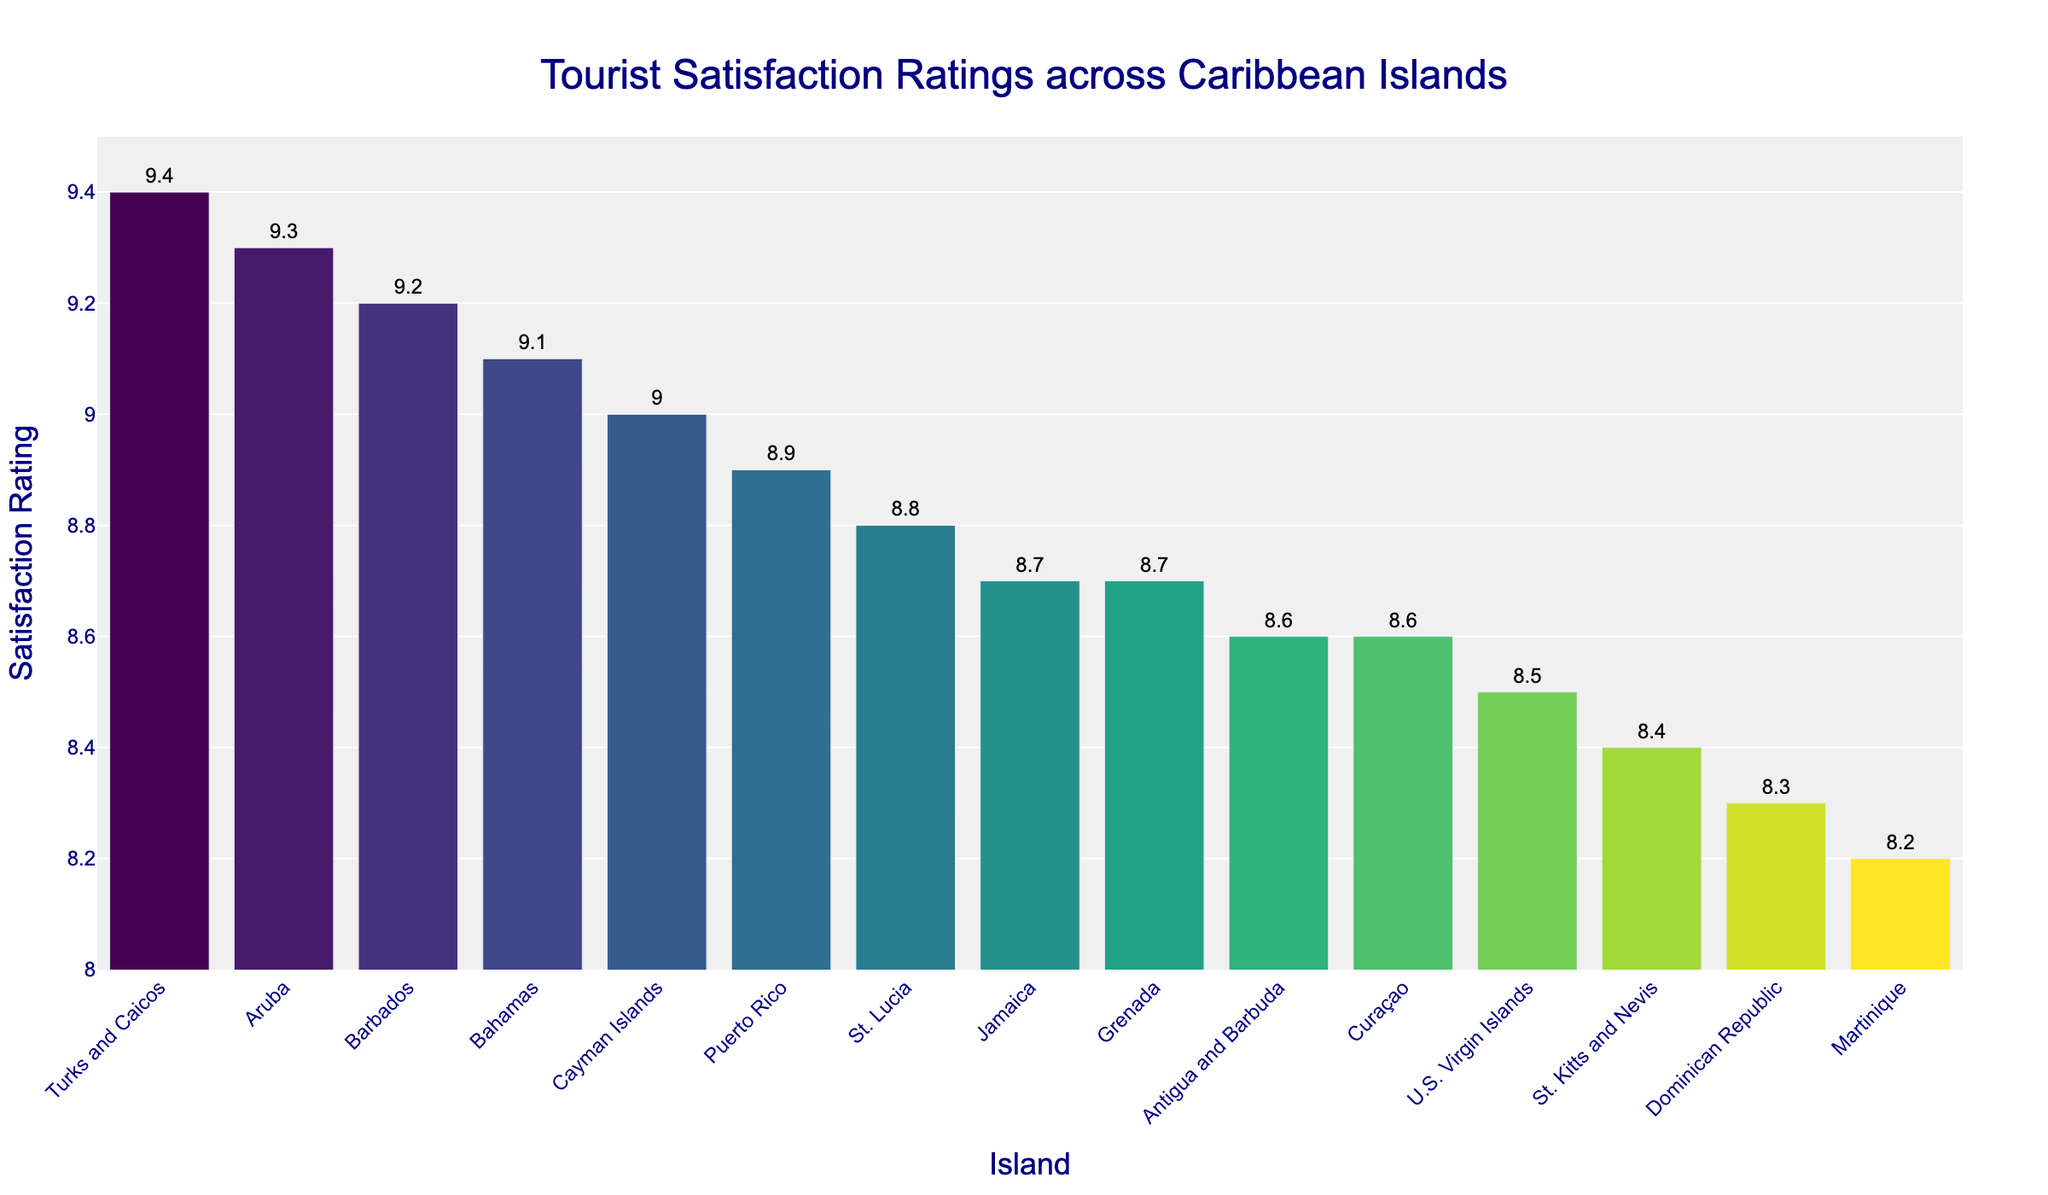What is the average satisfaction rating of the Caribbean islands in the chart? Add all the satisfaction ratings and divide by the number of islands: (8.7 + 9.1 + 8.3 + 8.9 + 9.2 + 8.8 + 9.3 + 9.0 + 9.4 + 8.6 + 8.5 + 8.7 + 8.4 + 8.6 + 8.2) / 15 = 132.7 / 15 = 8.8467
Answer: 8.85 Which island has the highest tourist satisfaction rating? The island with the tallest bar represents the highest satisfaction rating. That island is Turks and Caicos with a rating of 9.4
Answer: Turks and Caicos Which islands have a satisfaction rating of 9.0 or higher? Look for islands with bars that reach 9.0 or higher on the y-axis. These islands are Bahamas (9.1), Barbados (9.2), Aruba (9.3), Cayman Islands (9.0), and Turks and Caicos (9.4)
Answer: Bahamas, Barbados, Aruba, Cayman Islands, Turks and Caicos What is the difference in satisfaction rating between the highest and lowest rated islands? Subtract the lowest satisfaction rating from the highest: 9.4 (Turks and Caicos) - 8.2 (Martinique) = 1.2
Answer: 1.2 How many islands have a satisfaction rating below 8.5? Count the number of bars below the 8.5 mark on the y-axis. There are two such ratings: Dominican Republic (8.3) and Martinique (8.2)
Answer: 2 Which island has a satisfaction rating closest to the average rating? Compare the average rating of 8.85 with each island's rating and find the closest. St. Lucia has a rating of 8.8, which is closest to 8.85
Answer: St. Lucia What is the range of satisfaction ratings? Subtract the lowest rating from the highest rating to find the range: 9.4 (Turks and Caicos) - 8.2 (Martinique) = 1.2
Answer: 1.2 Which island has a rating equal to the median satisfaction rating of all islands? To find the median, list all the ratings in order: [8.2, 8.3, 8.4, 8.5, 8.6, 8.6, 8.7, 8.7, 8.8, 8.9, 9.0, 9.1, 9.2, 9.3, 9.4]. The median is the 8th value, which is 8.7. Jamaica and Grenada have this rating.
Answer: Jamaica and Grenada 